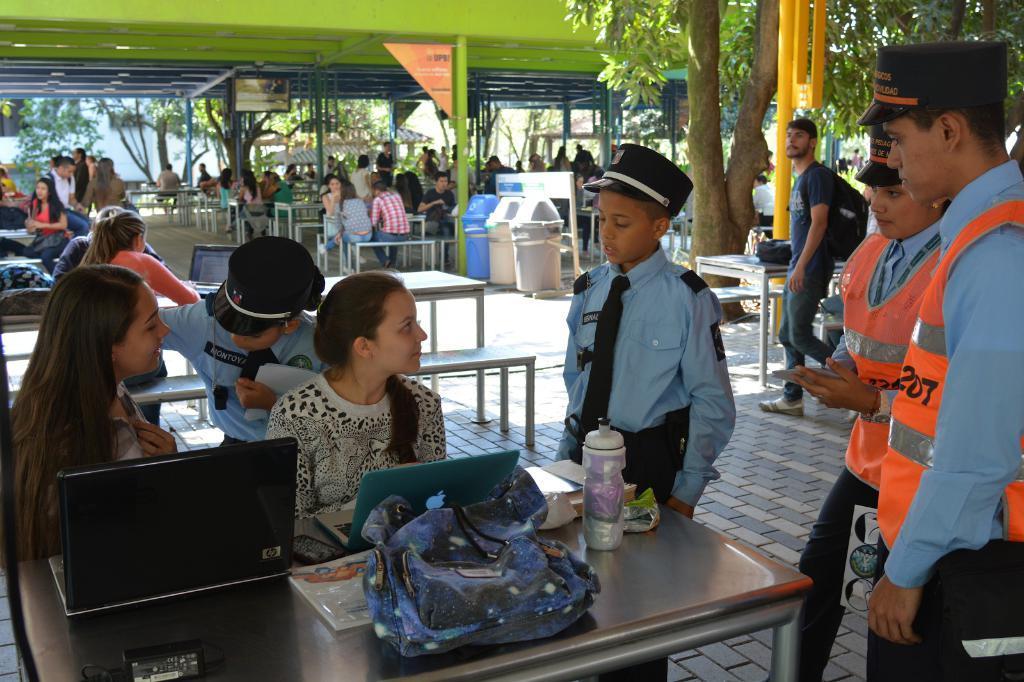Please provide a concise description of this image. In the foreground of this picture, there is a table on which laptops, a bag, a bottle and books are placed on it and there are two women sitting in front of a table. There are four police standing near the table. In the background, we can see the persons sitting near the tables, baskets, flags, a TV, tree and a person walking on the right side of the image. 